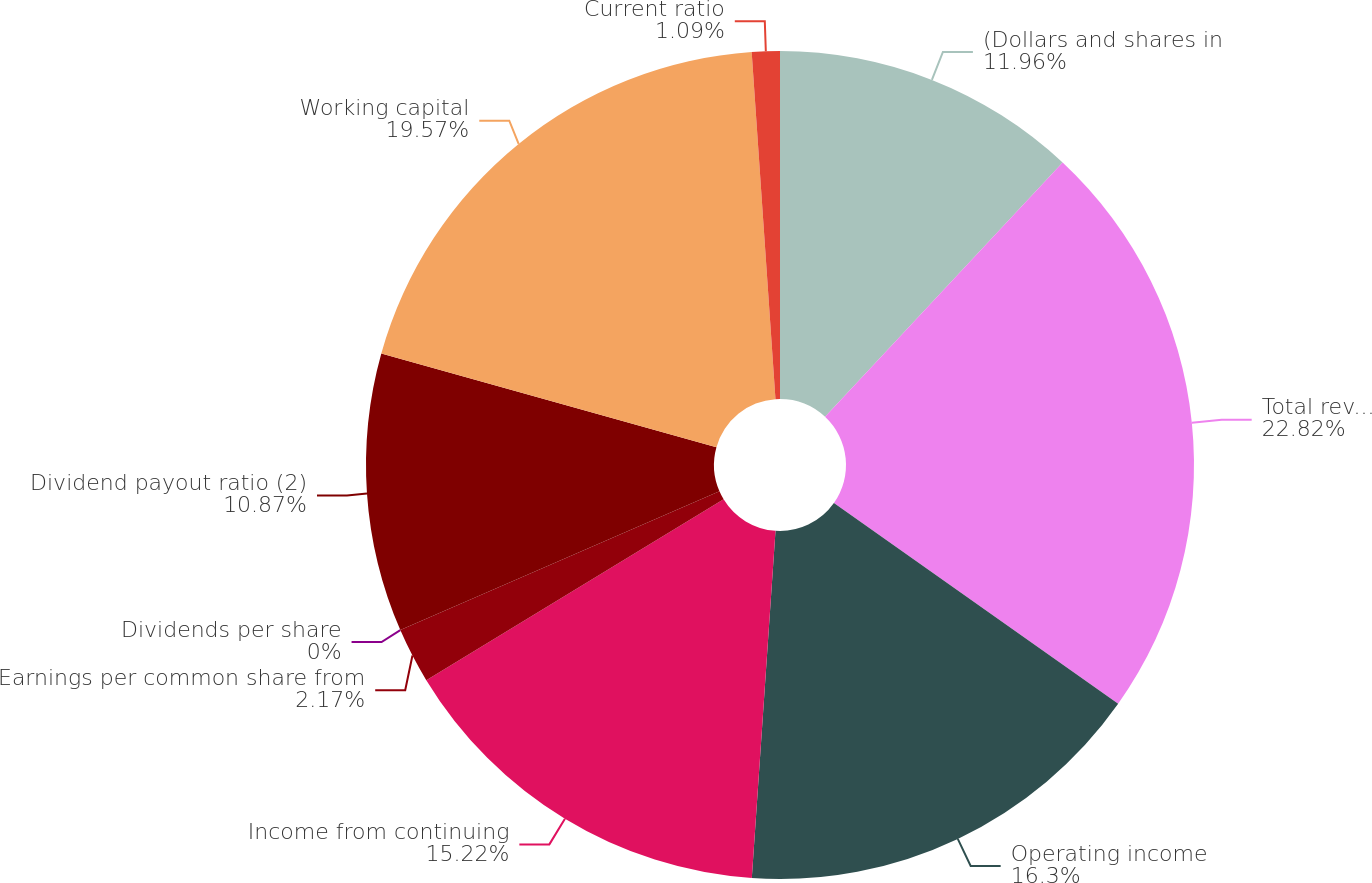Convert chart. <chart><loc_0><loc_0><loc_500><loc_500><pie_chart><fcel>(Dollars and shares in<fcel>Total revenues<fcel>Operating income<fcel>Income from continuing<fcel>Earnings per common share from<fcel>Dividends per share<fcel>Dividend payout ratio (2)<fcel>Working capital<fcel>Current ratio<nl><fcel>11.96%<fcel>22.83%<fcel>16.3%<fcel>15.22%<fcel>2.17%<fcel>0.0%<fcel>10.87%<fcel>19.57%<fcel>1.09%<nl></chart> 